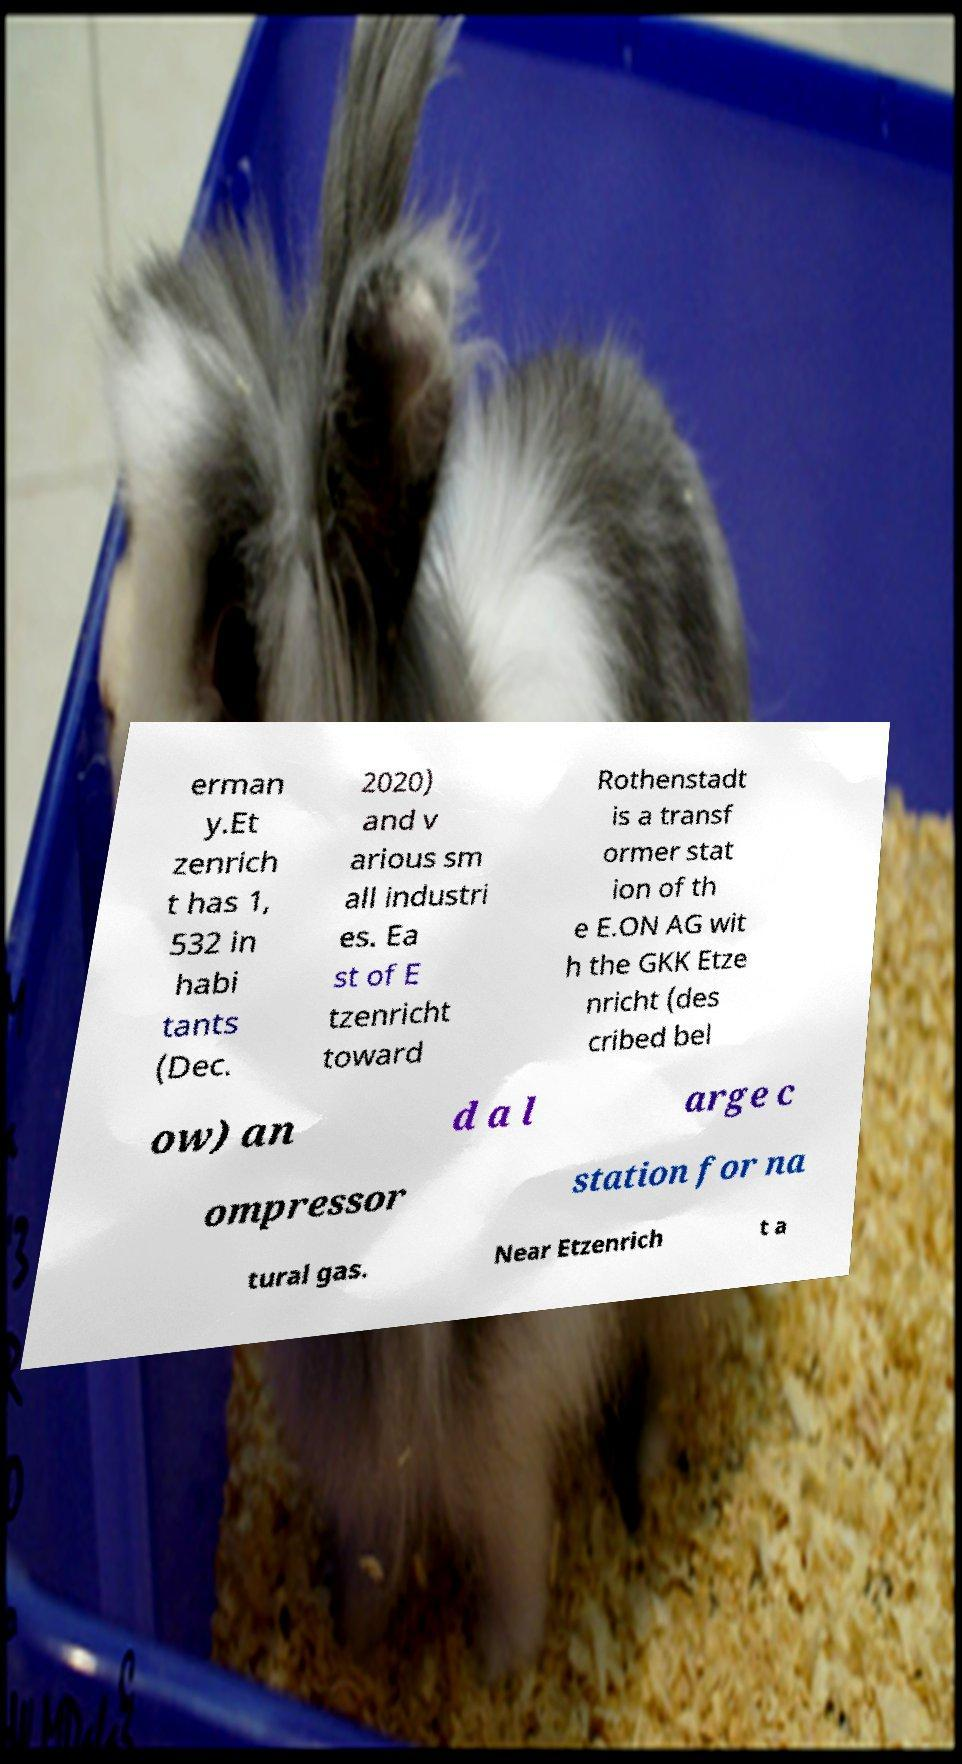Can you read and provide the text displayed in the image?This photo seems to have some interesting text. Can you extract and type it out for me? erman y.Et zenrich t has 1, 532 in habi tants (Dec. 2020) and v arious sm all industri es. Ea st of E tzenricht toward Rothenstadt is a transf ormer stat ion of th e E.ON AG wit h the GKK Etze nricht (des cribed bel ow) an d a l arge c ompressor station for na tural gas. Near Etzenrich t a 